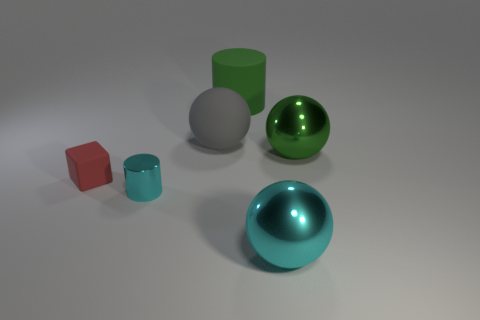Is the number of objects less than the number of small purple matte blocks?
Your response must be concise. No. There is a cylinder behind the small rubber cube; is its size the same as the metal object in front of the small shiny cylinder?
Your answer should be compact. Yes. What number of green objects are big things or spheres?
Ensure brevity in your answer.  2. There is a metallic ball that is the same color as the small metal cylinder; what is its size?
Your response must be concise. Large. Is the number of big green balls greater than the number of big blocks?
Your response must be concise. Yes. Do the rubber cube and the small shiny cylinder have the same color?
Ensure brevity in your answer.  No. How many objects are either gray objects or objects right of the large gray rubber sphere?
Your answer should be compact. 4. What number of other things are there of the same shape as the gray matte object?
Ensure brevity in your answer.  2. Is the number of green rubber objects to the left of the large gray sphere less than the number of small red blocks on the right side of the green shiny thing?
Provide a short and direct response. No. Is there anything else that is made of the same material as the big gray thing?
Provide a succinct answer. Yes. 